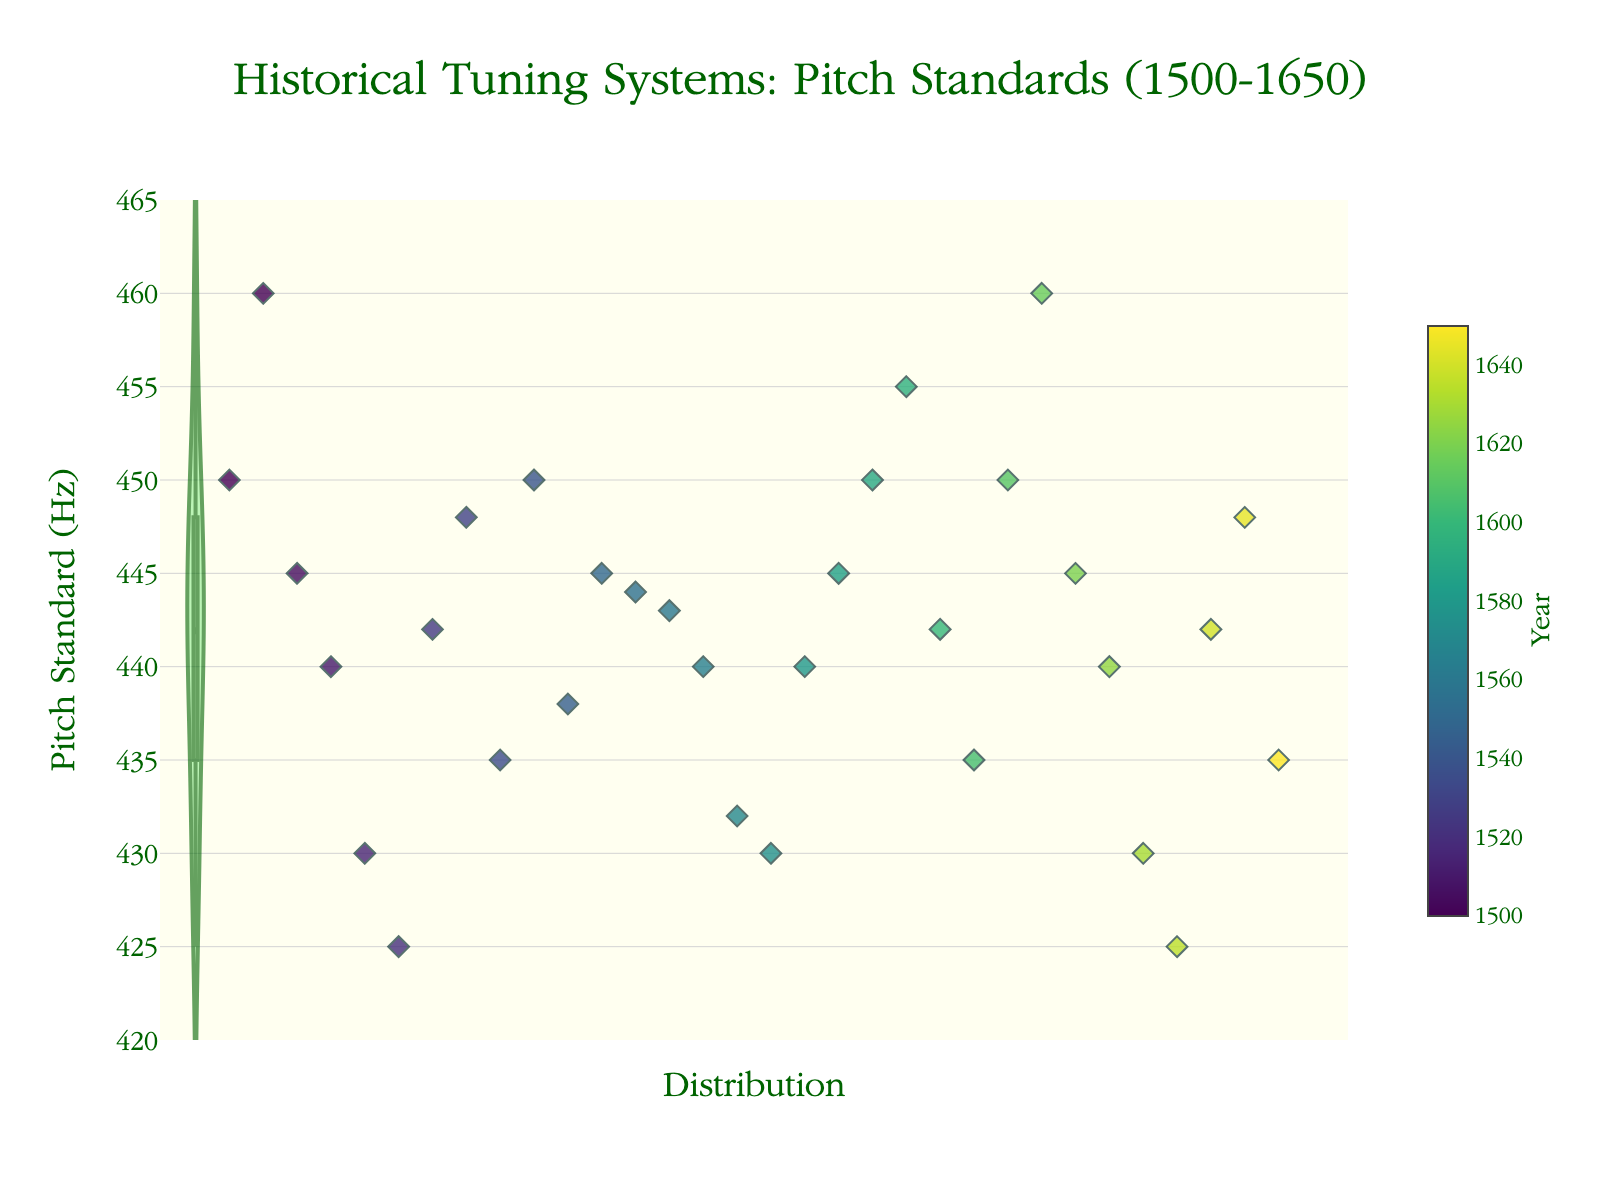Which instrument is the plot concerned with? The title of the plot is "Historical Tuning Systems: Pitch Standards (1500-1650)" which indicates that it is concerned with pitch standards. Since you are learning about early music and the violin plot with jittered points is shown, it suggests the pitch standards concern instruments like the recorder.
Answer: Recorder What is the range of pitch standards shown in the figure? By observing the y-axis, the pitch standards range from 420 Hz to 465 Hz.
Answer: 420 Hz to 465 Hz What are the periods of the individual data points in the figure? The color scale on the scatter plot indicates period years, where the points are colored according to the years they represent. The data ranges from 1500 to 1650.
Answer: 1500 to 1650 How many total data points are plotted? Counting all the jittered points in the scatter plot will give us the total number of data points. There are 30 points, each representing different locations and periods.
Answer: 30 Which period has the highest pitch standard? From the scatter plot, the highest pitch standard, close to 460 Hz, is represented by the points which belong to the periods around 1500, 1615, and Florence specifically.
Answer: 1615 What is the mean pitch standard around the early 1600s (1600-1650)? Observing the spread and central tendency from the violin plot (meanline) and checking the jittered points from the periods 1600 to 1650, we estimate the mean. The meanline in the violin suggests a mean pitch standard around 440 Hz-445 Hz.
Answer: 442 Hz (approx.) How does the pitch standard around 1500 compare with the pitch standard around 1650? By comparing the jittered points and their density in the violin plot for periods around 1500 and then at 1650, we notice that pitch standards in 1500 have higher variations and generally higher values compared to those around 1650.
Answer: Higher in 1500 What is the median value of the pitch standards between 1500 and 1650? The violin plot's internal box represents the interquartile range (IQR) with the median line inside it. The median is around 442 Hz, which is a clear indication of the central tendency.
Answer: 442 Hz Which location shows more consistent pitch standards? By comparing jittered points across various years for specific locations, cities like Milan and Rome consistently show values around 440 Hz-442 Hz, while some places like Florence have wider variations.
Answer: Milan/Rome How can one identify which individual points belong to the period around 1600? By observing the color of the individual jittered points and referencing the color bar indicating year values on the right side of the plot, points around 1600 are more bluish to green in hue.
Answer: Bluish to green hue 